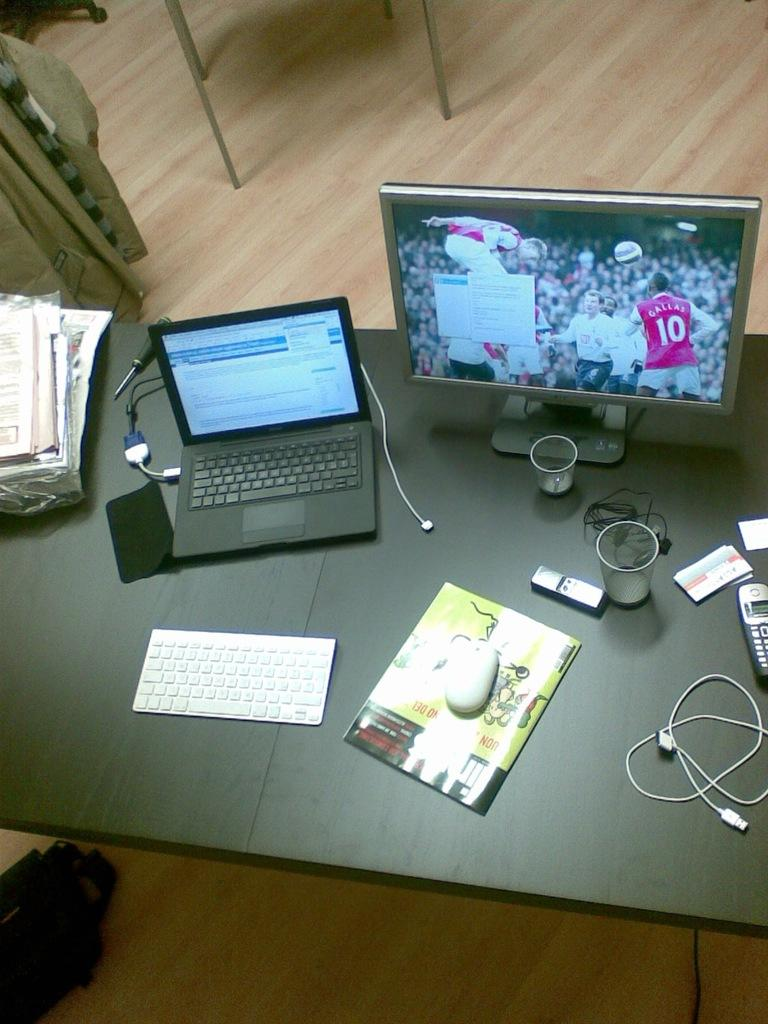<image>
Summarize the visual content of the image. A athlete wearing a 10 jersey on a TV screen. 